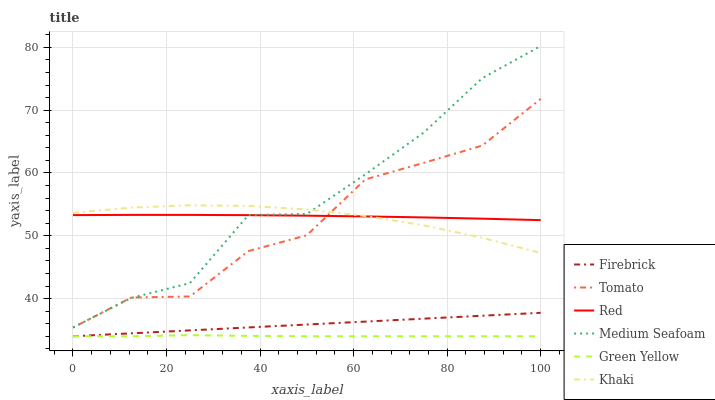Does Green Yellow have the minimum area under the curve?
Answer yes or no. Yes. Does Medium Seafoam have the maximum area under the curve?
Answer yes or no. Yes. Does Khaki have the minimum area under the curve?
Answer yes or no. No. Does Khaki have the maximum area under the curve?
Answer yes or no. No. Is Firebrick the smoothest?
Answer yes or no. Yes. Is Tomato the roughest?
Answer yes or no. Yes. Is Khaki the smoothest?
Answer yes or no. No. Is Khaki the roughest?
Answer yes or no. No. Does Khaki have the lowest value?
Answer yes or no. No. Does Khaki have the highest value?
Answer yes or no. No. Is Green Yellow less than Tomato?
Answer yes or no. Yes. Is Khaki greater than Green Yellow?
Answer yes or no. Yes. Does Green Yellow intersect Tomato?
Answer yes or no. No. 